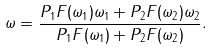<formula> <loc_0><loc_0><loc_500><loc_500>\omega = \frac { P _ { 1 } F ( \omega _ { 1 } ) \omega _ { 1 } + P _ { 2 } F ( \omega _ { 2 } ) \omega _ { 2 } } { P _ { 1 } F ( \omega _ { 1 } ) + P _ { 2 } F ( \omega _ { 2 } ) } .</formula> 